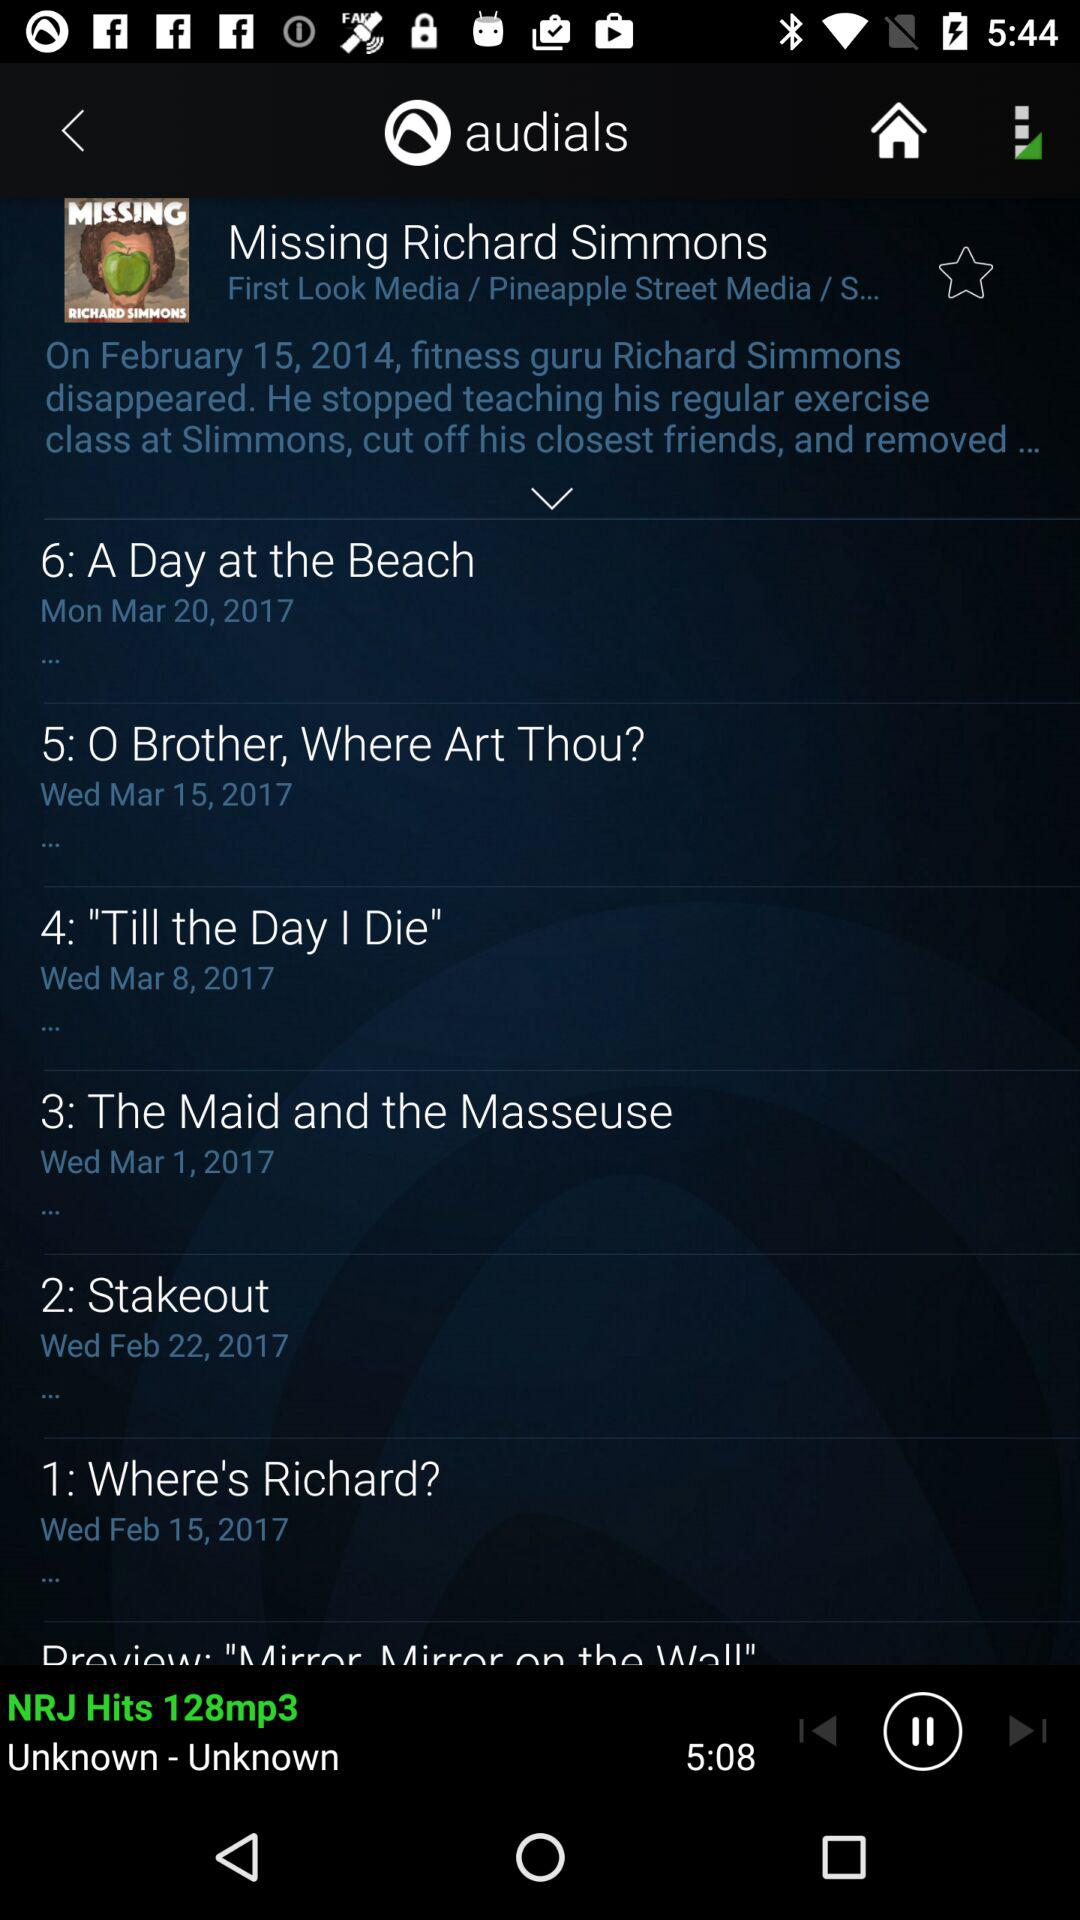What is the date for "Stakeout"? The date for "Stakeout" is Wednesday, February 22, 2017. 